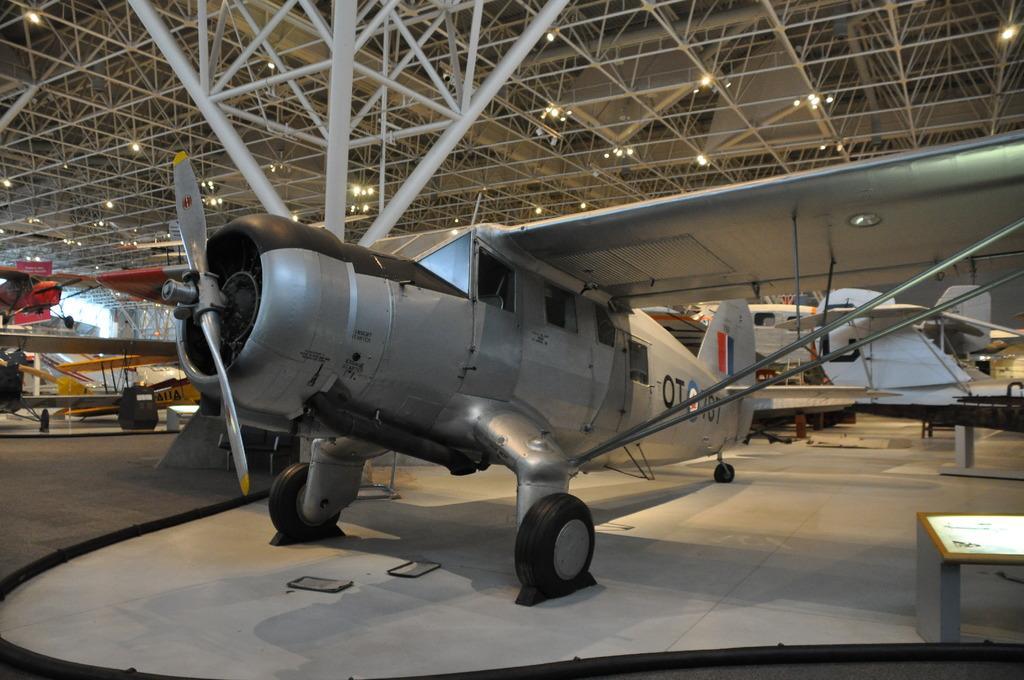How would you summarize this image in a sentence or two? In this image I can see in the middle it is an aeroplane in grey color. At the top there are lights. It looks like a shed. 